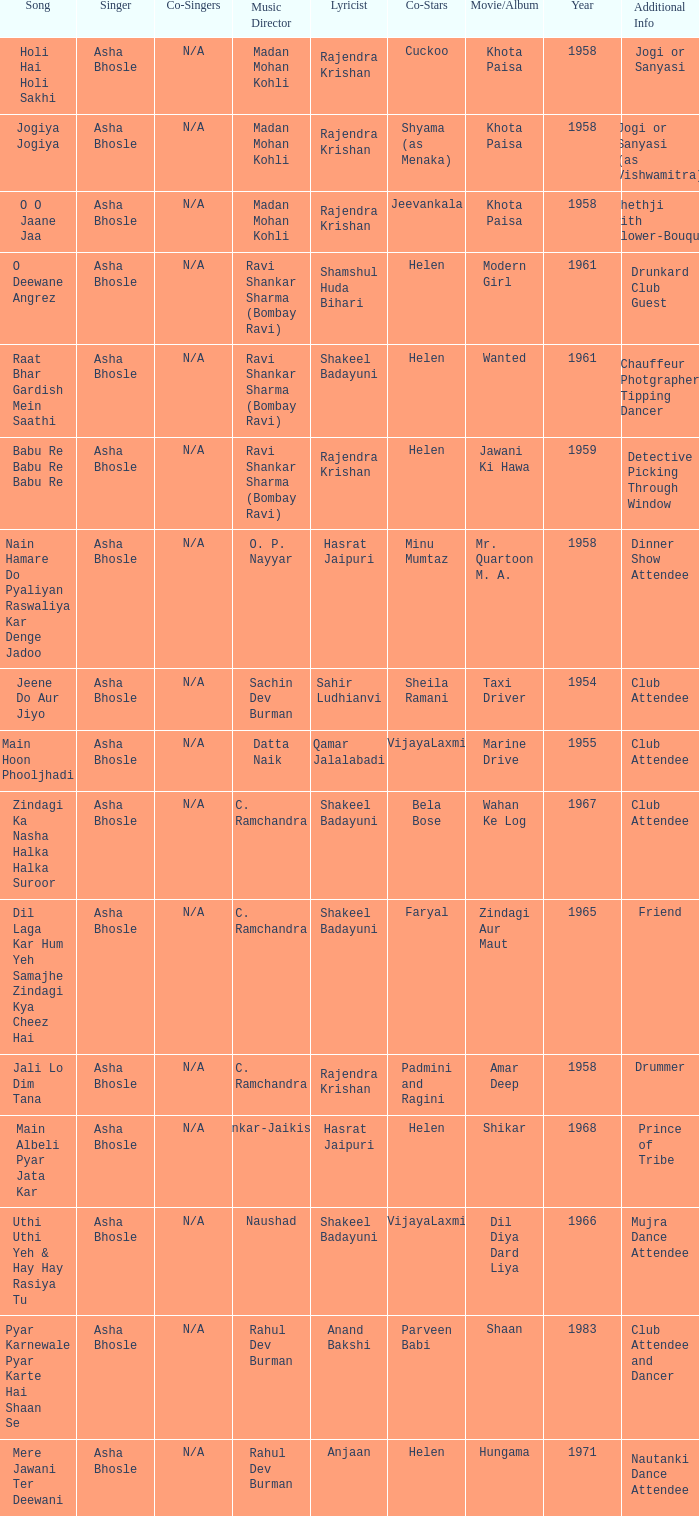Can you parse all the data within this table? {'header': ['Song', 'Singer', 'Co-Singers', 'Music Director', 'Lyricist', 'Co-Stars', 'Movie/Album', 'Year', 'Additional Info'], 'rows': [['Holi Hai Holi Sakhi', 'Asha Bhosle', 'N/A', 'Madan Mohan Kohli', 'Rajendra Krishan', 'Cuckoo', 'Khota Paisa', '1958', 'Jogi or Sanyasi'], ['Jogiya Jogiya', 'Asha Bhosle', 'N/A', 'Madan Mohan Kohli', 'Rajendra Krishan', 'Shyama (as Menaka)', 'Khota Paisa', '1958', 'Jogi or Sanyasi (as Vishwamitra)'], ['O O Jaane Jaa', 'Asha Bhosle', 'N/A', 'Madan Mohan Kohli', 'Rajendra Krishan', 'Jeevankala', 'Khota Paisa', '1958', 'Shethji with flower-Bouque'], ['O Deewane Angrez', 'Asha Bhosle', 'N/A', 'Ravi Shankar Sharma (Bombay Ravi)', 'Shamshul Huda Bihari', 'Helen', 'Modern Girl', '1961', 'Drunkard Club Guest'], ['Raat Bhar Gardish Mein Saathi', 'Asha Bhosle', 'N/A', 'Ravi Shankar Sharma (Bombay Ravi)', 'Shakeel Badayuni', 'Helen', 'Wanted', '1961', 'Chauffeur Photgrapher Tipping Dancer'], ['Babu Re Babu Re Babu Re', 'Asha Bhosle', 'N/A', 'Ravi Shankar Sharma (Bombay Ravi)', 'Rajendra Krishan', 'Helen', 'Jawani Ki Hawa', '1959', 'Detective Picking Through Window'], ['Nain Hamare Do Pyaliyan Raswaliya Kar Denge Jadoo', 'Asha Bhosle', 'N/A', 'O. P. Nayyar', 'Hasrat Jaipuri', 'Minu Mumtaz', 'Mr. Quartoon M. A.', '1958', 'Dinner Show Attendee'], ['Jeene Do Aur Jiyo', 'Asha Bhosle', 'N/A', 'Sachin Dev Burman', 'Sahir Ludhianvi', 'Sheila Ramani', 'Taxi Driver', '1954', 'Club Attendee'], ['Main Hoon Phooljhadi', 'Asha Bhosle', 'N/A', 'Datta Naik', 'Qamar Jalalabadi', 'VijayaLaxmi', 'Marine Drive', '1955', 'Club Attendee'], ['Zindagi Ka Nasha Halka Halka Suroor', 'Asha Bhosle', 'N/A', 'C. Ramchandra', 'Shakeel Badayuni', 'Bela Bose', 'Wahan Ke Log', '1967', 'Club Attendee'], ['Dil Laga Kar Hum Yeh Samajhe Zindagi Kya Cheez Hai', 'Asha Bhosle', 'N/A', 'C. Ramchandra', 'Shakeel Badayuni', 'Faryal', 'Zindagi Aur Maut', '1965', 'Friend'], ['Jali Lo Dim Tana', 'Asha Bhosle', 'N/A', 'C. Ramchandra', 'Rajendra Krishan', 'Padmini and Ragini', 'Amar Deep', '1958', 'Drummer'], ['Main Albeli Pyar Jata Kar', 'Asha Bhosle', 'N/A', 'Shankar-Jaikishan', 'Hasrat Jaipuri', 'Helen', 'Shikar', '1968', 'Prince of Tribe'], ['Uthi Uthi Yeh & Hay Hay Rasiya Tu', 'Asha Bhosle', 'N/A', 'Naushad', 'Shakeel Badayuni', 'VijayaLaxmi', 'Dil Diya Dard Liya', '1966', 'Mujra Dance Attendee'], ['Pyar Karnewale Pyar Karte Hai Shaan Se', 'Asha Bhosle', 'N/A', 'Rahul Dev Burman', 'Anand Bakshi', 'Parveen Babi', 'Shaan', '1983', 'Club Attendee and Dancer'], ['Mere Jawani Ter Deewani', 'Asha Bhosle', 'N/A', 'Rahul Dev Burman', 'Anjaan', 'Helen', 'Hungama', '1971', 'Nautanki Dance Attendee']]} Who provided the singing for the movie amar deep? Asha Bhosle. 